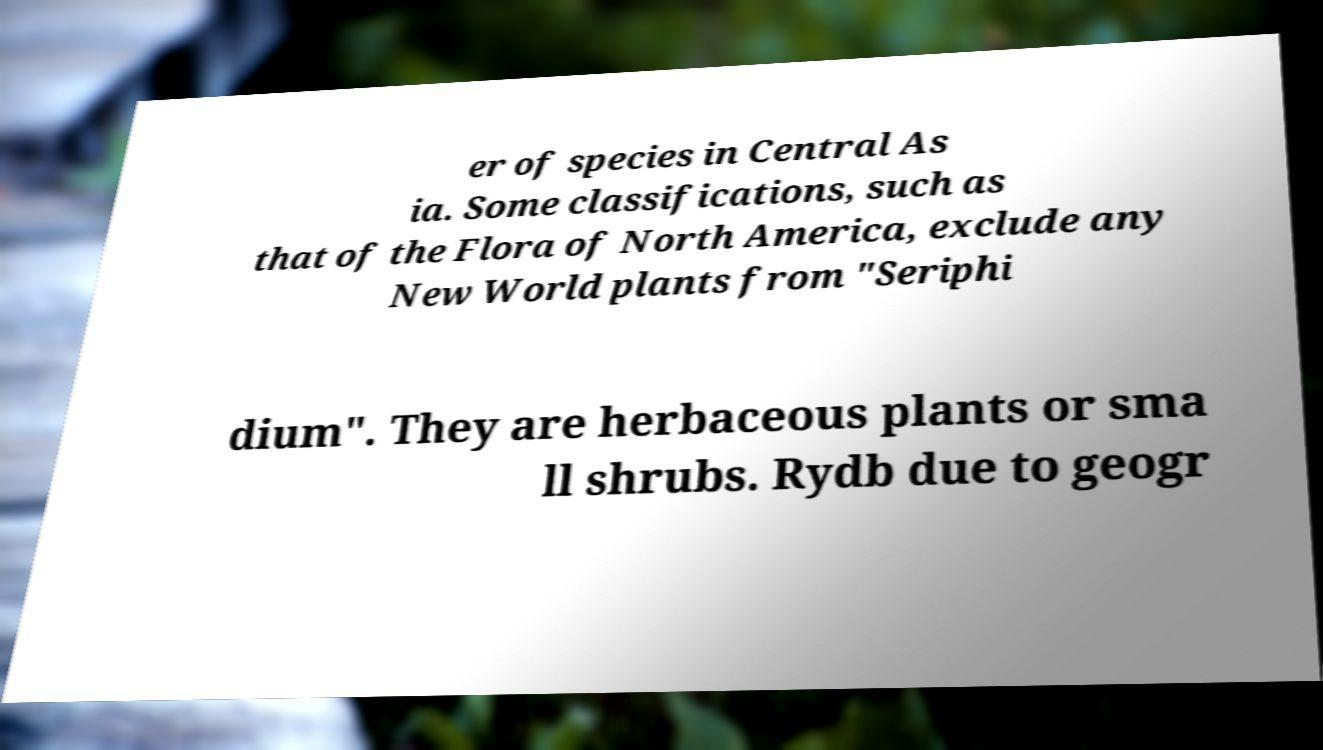What messages or text are displayed in this image? I need them in a readable, typed format. er of species in Central As ia. Some classifications, such as that of the Flora of North America, exclude any New World plants from "Seriphi dium". They are herbaceous plants or sma ll shrubs. Rydb due to geogr 